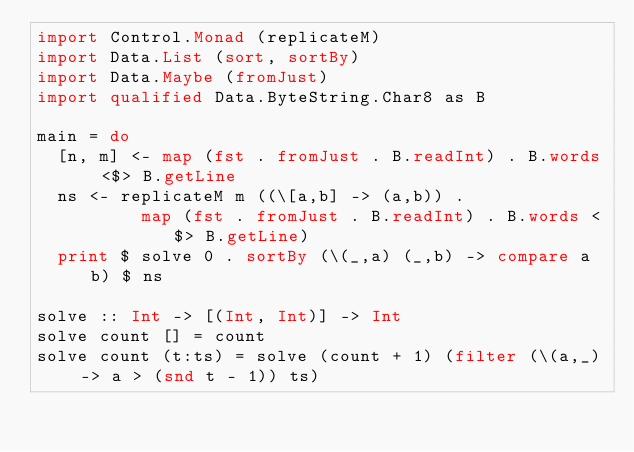<code> <loc_0><loc_0><loc_500><loc_500><_Haskell_>import Control.Monad (replicateM)
import Data.List (sort, sortBy)
import Data.Maybe (fromJust)
import qualified Data.ByteString.Char8 as B

main = do
  [n, m] <- map (fst . fromJust . B.readInt) . B.words <$> B.getLine 
  ns <- replicateM m ((\[a,b] -> (a,b)) . 
          map (fst . fromJust . B.readInt) . B.words <$> B.getLine)
  print $ solve 0 . sortBy (\(_,a) (_,b) -> compare a b) $ ns

solve :: Int -> [(Int, Int)] -> Int 
solve count [] = count 
solve count (t:ts) = solve (count + 1) (filter (\(a,_) -> a > (snd t - 1)) ts)</code> 